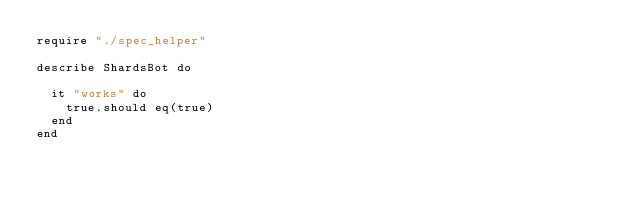<code> <loc_0><loc_0><loc_500><loc_500><_Crystal_>require "./spec_helper"

describe ShardsBot do

  it "works" do
    true.should eq(true)
  end
end
</code> 